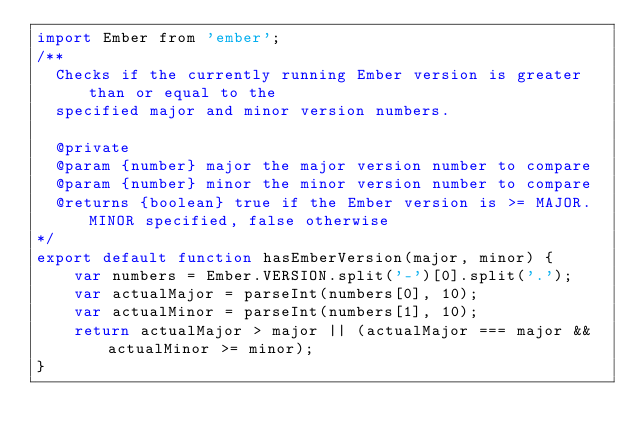<code> <loc_0><loc_0><loc_500><loc_500><_JavaScript_>import Ember from 'ember';
/**
  Checks if the currently running Ember version is greater than or equal to the
  specified major and minor version numbers.

  @private
  @param {number} major the major version number to compare
  @param {number} minor the minor version number to compare
  @returns {boolean} true if the Ember version is >= MAJOR.MINOR specified, false otherwise
*/
export default function hasEmberVersion(major, minor) {
    var numbers = Ember.VERSION.split('-')[0].split('.');
    var actualMajor = parseInt(numbers[0], 10);
    var actualMinor = parseInt(numbers[1], 10);
    return actualMajor > major || (actualMajor === major && actualMinor >= minor);
}
</code> 